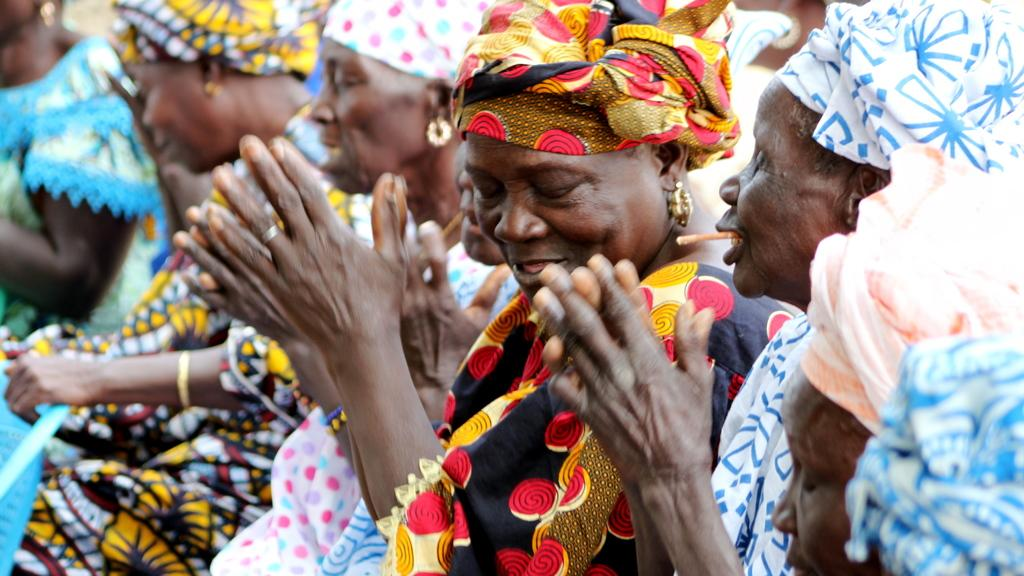Who is present in the image? There are women in the image. What are the women doing in the image? Some of the women are clapping. What type of breathing apparatus is visible in the image? There is no breathing apparatus present in the image. 